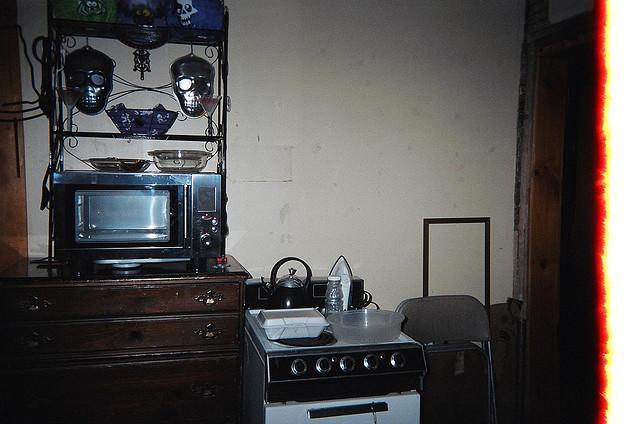How many bowls are there?
Give a very brief answer. 1. 